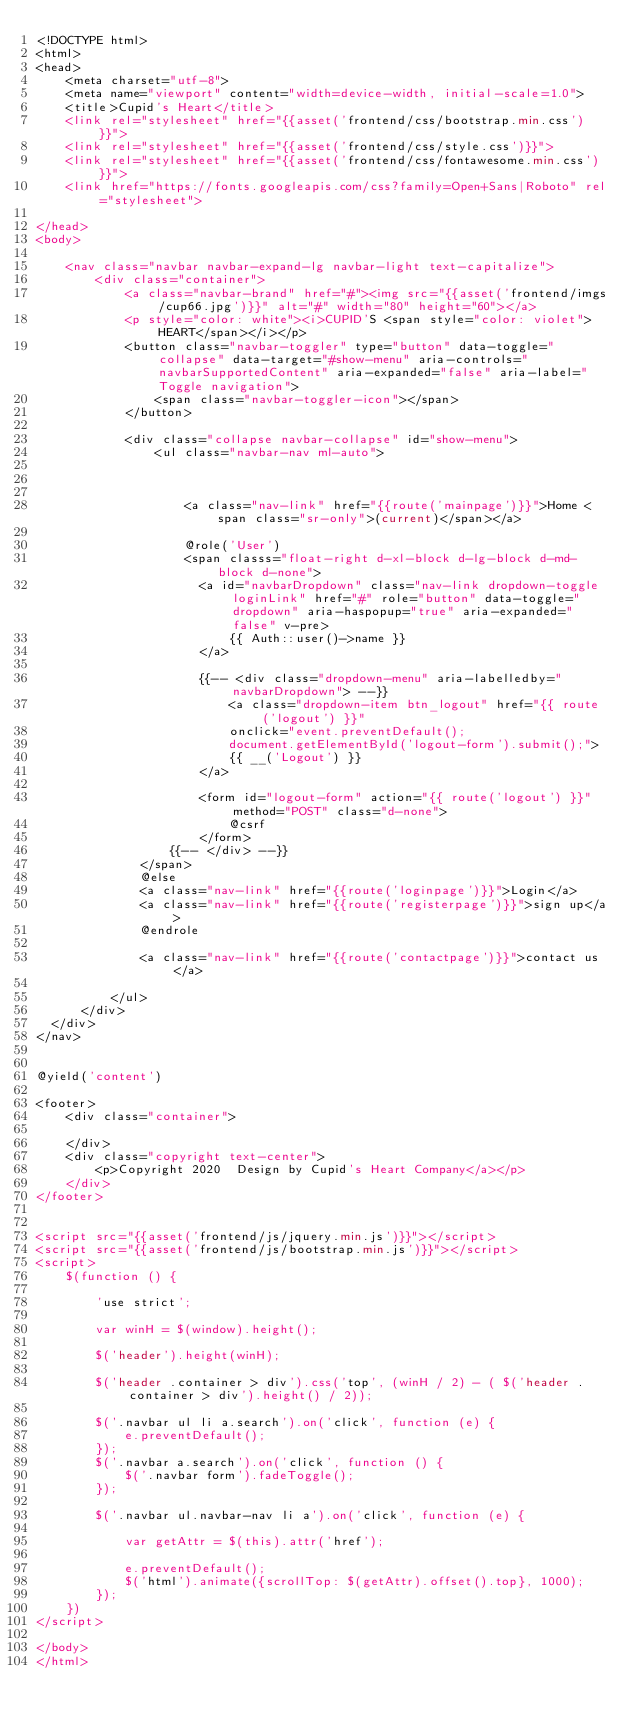Convert code to text. <code><loc_0><loc_0><loc_500><loc_500><_PHP_><!DOCTYPE html>
<html>
<head>
    <meta charset="utf-8">
    <meta name="viewport" content="width=device-width, initial-scale=1.0">
    <title>Cupid's Heart</title>
    <link rel="stylesheet" href="{{asset('frontend/css/bootstrap.min.css')}}">
    <link rel="stylesheet" href="{{asset('frontend/css/style.css')}}">
    <link rel="stylesheet" href="{{asset('frontend/css/fontawesome.min.css')}}">
    <link href="https://fonts.googleapis.com/css?family=Open+Sans|Roboto" rel="stylesheet">
    
</head>
<body>
    
    <nav class="navbar navbar-expand-lg navbar-light text-capitalize">
        <div class="container">
            <a class="navbar-brand" href="#"><img src="{{asset('frontend/imgs/cup66.jpg')}}" alt="#" width="80" height="60"></a>
            <p style="color: white"><i>CUPID'S <span style="color: violet">HEART</span></i></p>
            <button class="navbar-toggler" type="button" data-toggle="collapse" data-target="#show-menu" aria-controls="navbarSupportedContent" aria-expanded="false" aria-label="Toggle navigation">
                <span class="navbar-toggler-icon"></span>
            </button>

            <div class="collapse navbar-collapse" id="show-menu">
                <ul class="navbar-nav ml-auto">
                    
                    

                    <a class="nav-link" href="{{route('mainpage')}}">Home <span class="sr-only">(current)</span></a>
                    
                    @role('User')
                    <span classs="float-right d-xl-block d-lg-block d-md-block d-none">
                      <a id="navbarDropdown" class="nav-link dropdown-toggle loginLink" href="#" role="button" data-toggle="dropdown" aria-haspopup="true" aria-expanded="false" v-pre>
                          {{ Auth::user()->name }}
                      </a>

                      {{-- <div class="dropdown-menu" aria-labelledby="navbarDropdown"> --}}
                          <a class="dropdown-item btn_logout" href="{{ route('logout') }}"
                          onclick="event.preventDefault();
                          document.getElementById('logout-form').submit();">
                          {{ __('Logout') }}
                      </a>

                      <form id="logout-form" action="{{ route('logout') }}" method="POST" class="d-none">
                          @csrf
                      </form>
                  {{-- </div> --}}
              </span>
              @else
              <a class="nav-link" href="{{route('loginpage')}}">Login</a>
              <a class="nav-link" href="{{route('registerpage')}}">sign up</a>
              @endrole
              
              <a class="nav-link" href="{{route('contactpage')}}">contact us</a>
              
          </ul>
      </div>
  </div>
</nav>


@yield('content')

<footer>
    <div class="container">
        
    </div>
    <div class="copyright text-center">
        <p>Copyright 2020  Design by Cupid's Heart Company</a></p>
    </div>
</footer>

                  
<script src="{{asset('frontend/js/jquery.min.js')}}"></script>
<script src="{{asset('frontend/js/bootstrap.min.js')}}"></script>
<script>
    $(function () {
        
        'use strict';
        
        var winH = $(window).height();
        
        $('header').height(winH);  
        
        $('header .container > div').css('top', (winH / 2) - ( $('header .container > div').height() / 2));
        
        $('.navbar ul li a.search').on('click', function (e) {
            e.preventDefault();
        });
        $('.navbar a.search').on('click', function () {
            $('.navbar form').fadeToggle();
        });
        
        $('.navbar ul.navbar-nav li a').on('click', function (e) {
            
            var getAttr = $(this).attr('href');
            
            e.preventDefault();
            $('html').animate({scrollTop: $(getAttr).offset().top}, 1000);
        });
    })
</script>

</body>
</html></code> 